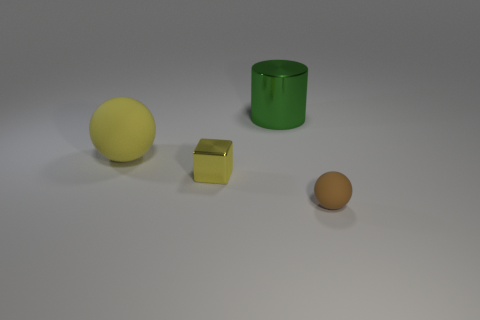Are any big red matte things visible?
Provide a succinct answer. No. Is the number of yellow objects right of the small yellow metallic thing less than the number of large shiny objects on the right side of the big metal cylinder?
Offer a terse response. No. What is the shape of the small object to the right of the block?
Provide a short and direct response. Sphere. Is the material of the large yellow thing the same as the small brown object?
Offer a terse response. Yes. Is there anything else that is made of the same material as the small yellow cube?
Your answer should be compact. Yes. There is a brown object that is the same shape as the yellow matte object; what material is it?
Your answer should be compact. Rubber. Is the number of yellow metallic cubes on the right side of the green cylinder less than the number of big red cylinders?
Give a very brief answer. No. What number of metallic blocks are on the right side of the cube?
Provide a succinct answer. 0. There is a tiny thing that is left of the big green cylinder; is it the same shape as the rubber object that is on the left side of the big green metallic object?
Your answer should be compact. No. There is a object that is both in front of the large matte sphere and on the right side of the metal cube; what shape is it?
Provide a short and direct response. Sphere. 